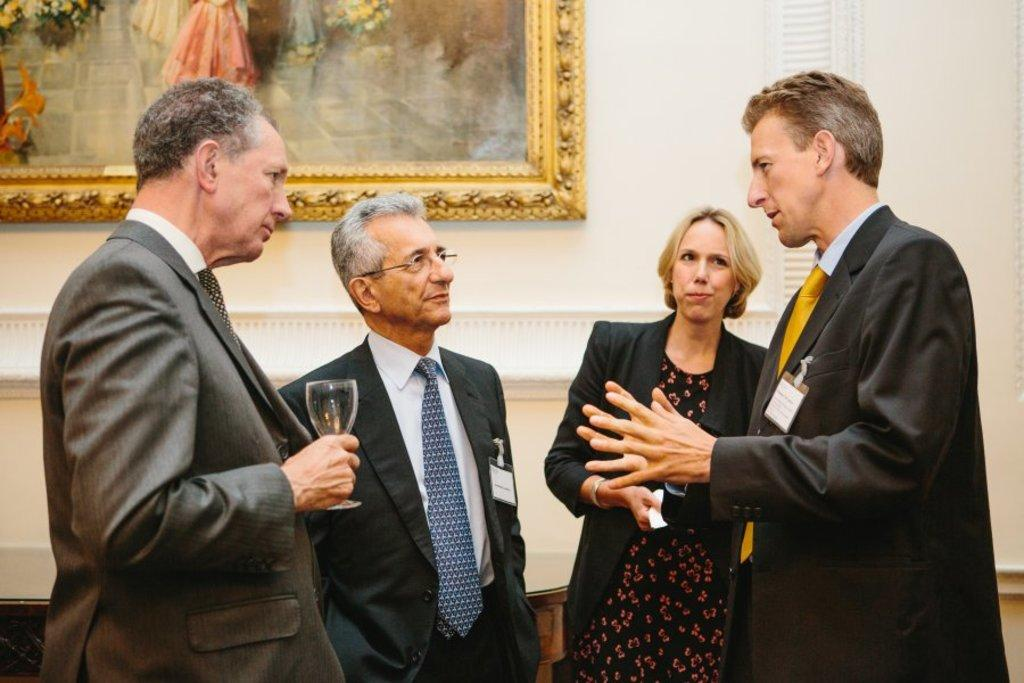How many people are present in the image? There are four people in the image. What is one person holding in the image? One person is holding a glass. What are the people wearing in the image? All four people are wearing suits. Where is the image located? The image is on a white wall. What is the interaction between the people in the image? Three people are looking at one man. What type of attention is the donkey receiving from the people in the image? There is no donkey present in the image, so it cannot receive any attention from the people. 